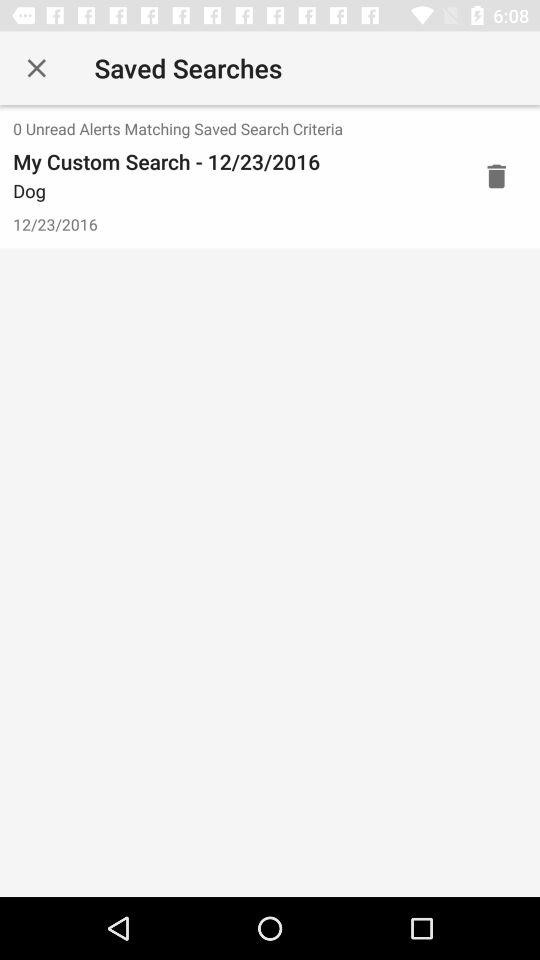What is the given date? The given date is December 23, 2016. 